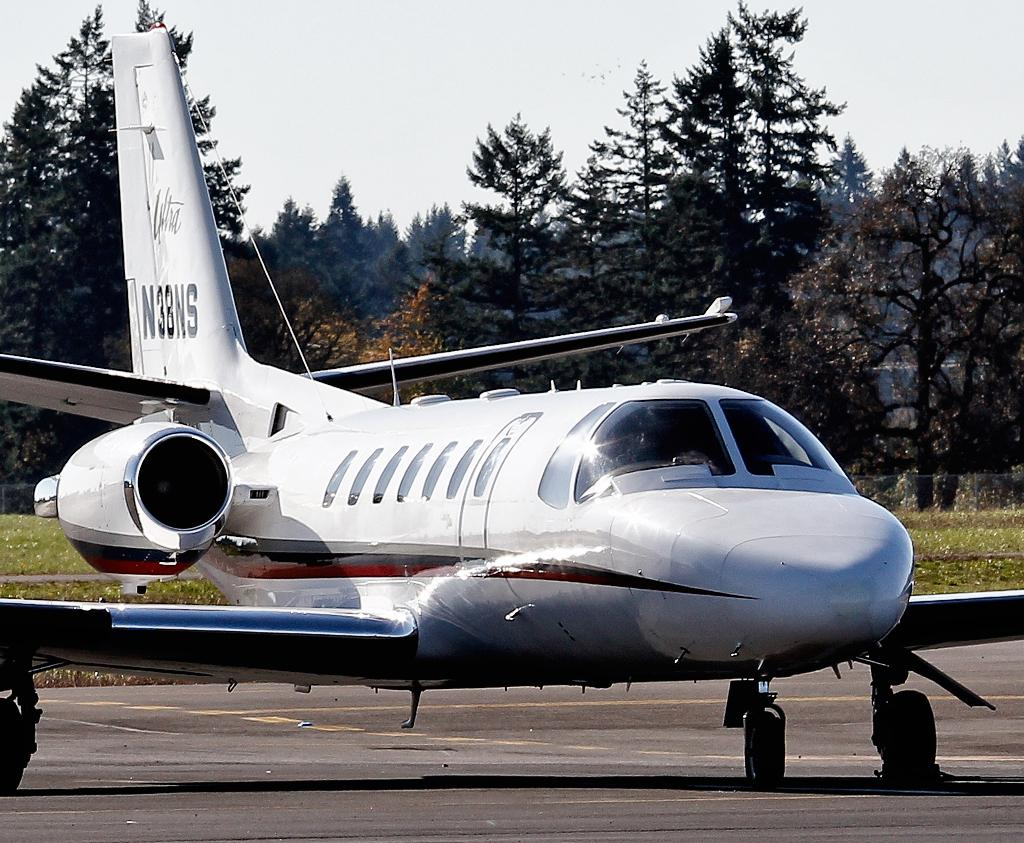What is the main subject of the image? The main subject of the image is an airplane on the runway. What can be seen in the middle of the image? There are plants and grass in the middle of the image. What is visible in the background of the image? There are trees in the background of the image. What is visible at the top of the image? The sky is visible at the top of the image. How many giants are visible in the image? There are no giants present in the image. What does the uncle of the person taking the picture look like? There is no information about an uncle or the person taking the picture in the image. 